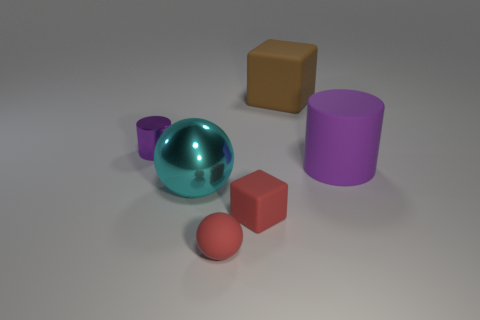Is the color of the block that is in front of the matte cylinder the same as the large metallic sphere?
Keep it short and to the point. No. Are there any other things that are the same shape as the brown object?
Provide a short and direct response. Yes. There is a tiny rubber thing on the right side of the small sphere; is there a cyan metal thing that is on the right side of it?
Offer a very short reply. No. Is the number of tiny red matte balls that are in front of the big rubber cylinder less than the number of purple metal things that are behind the brown object?
Ensure brevity in your answer.  No. There is a shiny thing behind the large thing in front of the purple cylinder that is on the right side of the purple metallic thing; what is its size?
Offer a terse response. Small. Does the rubber block in front of the brown matte block have the same size as the large purple thing?
Provide a succinct answer. No. What number of other objects are there of the same material as the tiny purple cylinder?
Make the answer very short. 1. Is the number of small metallic cylinders greater than the number of big cyan cylinders?
Make the answer very short. Yes. There is a purple object that is to the right of the rubber thing that is behind the cylinder behind the purple matte cylinder; what is its material?
Your answer should be compact. Rubber. Is the color of the tiny metal thing the same as the large ball?
Offer a terse response. No. 